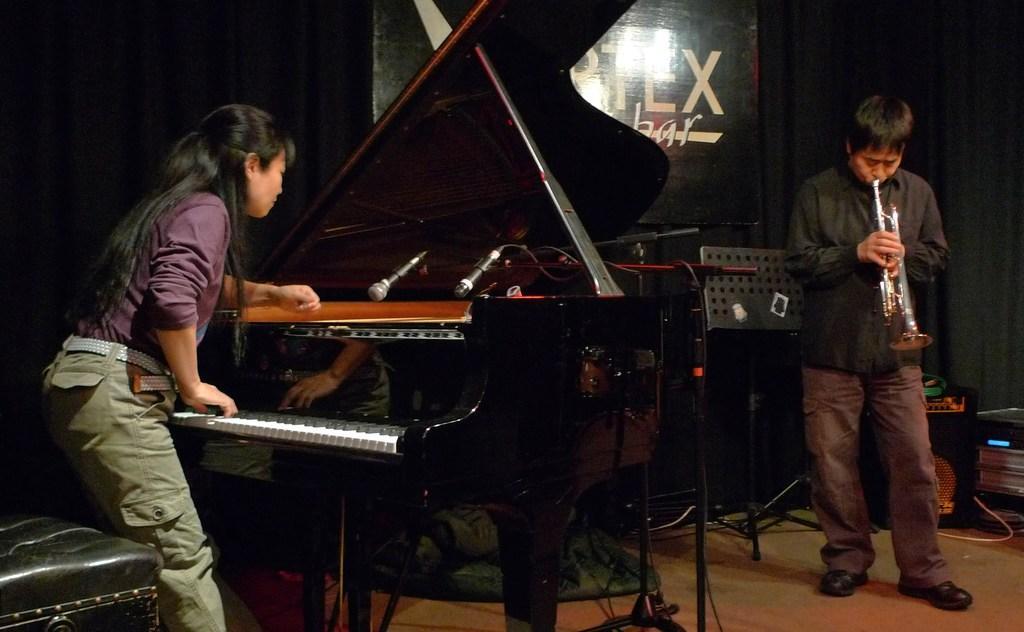How would you summarize this image in a sentence or two? In this image we can see two people on the left side the woman is playing piano and in front of the piano there are microphones and at the right side the man is playing a saxophone and behind them there are various musical instruments present 